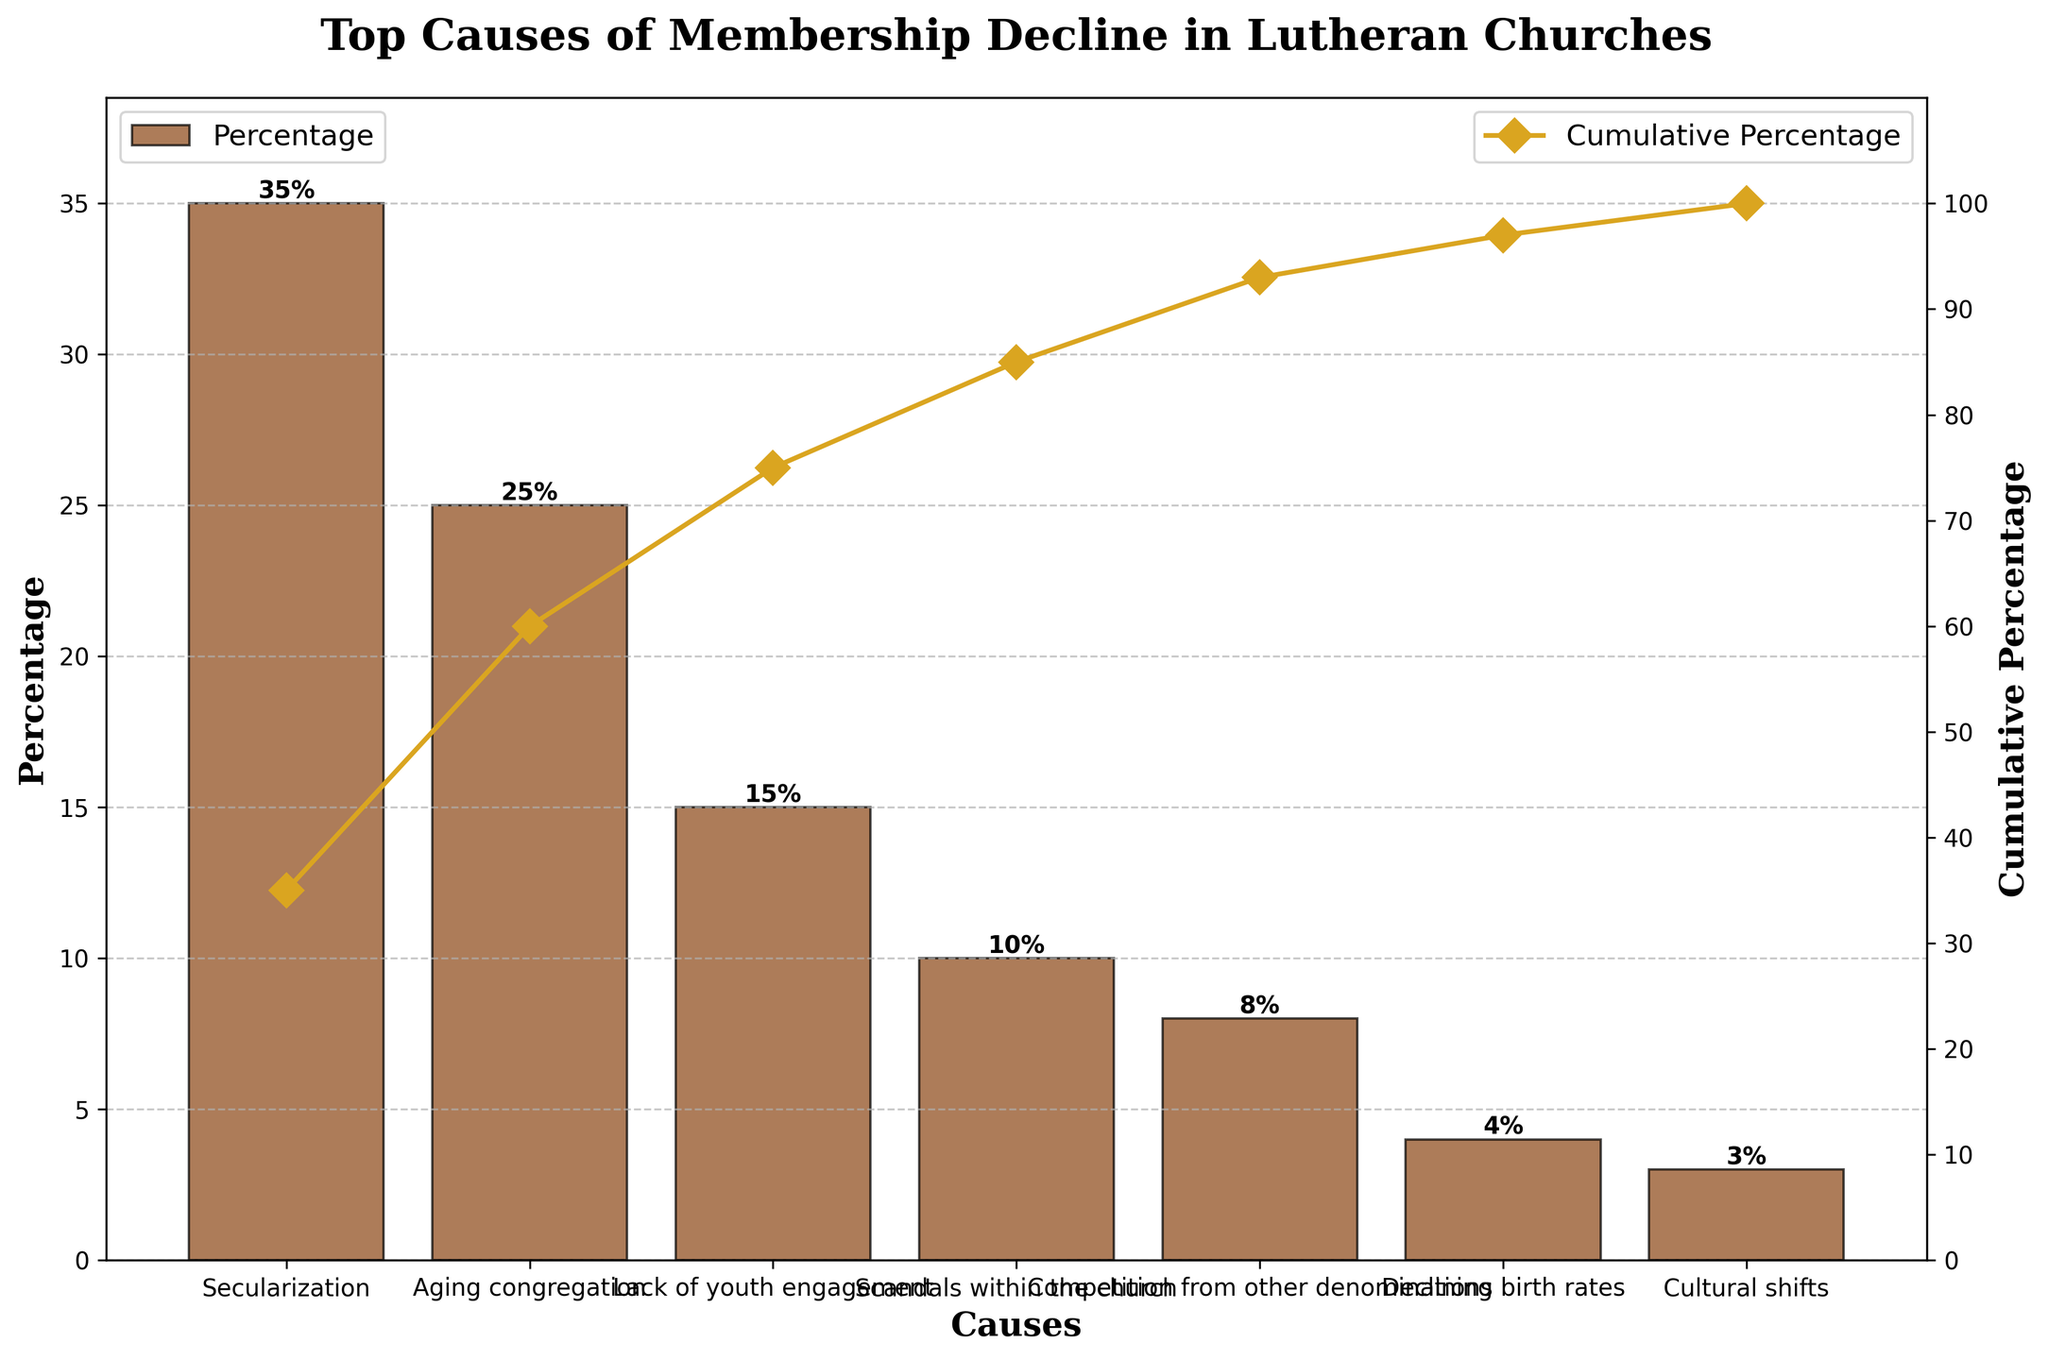How many causes of membership decline are listed? Count the number of bars on the x-axis; each bar represents a cause. There are 7 bars indicating 7 causes.
Answer: 7 What is the primary cause of membership decline in Lutheran churches? Identify the tallest bar in the plot, which represents the cause with the highest percentage. The tallest bar is for Secularization at 35%.
Answer: Secularization By how much does the impact of 'Aging congregation' differ from 'Lack of youth engagement'? Check the percentages for 'Aging congregation' (25%) and 'Lack of youth engagement' (15%). Subtract the smaller percentage from the larger one: 25% - 15% = 10%.
Answer: 10% Which causes account for over half of the membership decline? Calculate the cumulative percentages from the left and identify where the sum exceeds 50%. Secularization (35%) and Aging congregation (25%) together make 60%, which is over half.
Answer: Secularization and Aging congregation What is the cumulative percentage for the first three causes? Sum the percentages of the first three causes: Secularization (35%), Aging congregation (25%), and Lack of youth engagement (15%). 35% + 25% + 15% = 75%.
Answer: 75% How much impact do 'Scandals within the church' and 'Competition from other denominations' have combined? Add the percentages of 'Scandals within the church' (10%) and 'Competition from other denominations' (8%): 10% + 8% = 18%.
Answer: 18% Which cause has the least impact on membership decline? Identify the shortest bar in the plot, which represents the cause with the smallest percentage. The shortest bar is Cultural shifts at 3%.
Answer: Cultural shifts How does the impact of 'Declining birth rates' compare to 'Cultural shifts'? Check the percentages for Declining birth rates (4%) and Cultural shifts (3%). Compare the two: 4% is greater than 3%.
Answer: Declining birth rates What percentage of the decline is due to 'Cultural shifts' and 'Declining birth rates' together? Sum the percentages of 'Cultural shifts' (3%) and 'Declining birth rates' (4%): 3% + 4% = 7%.
Answer: 7% 